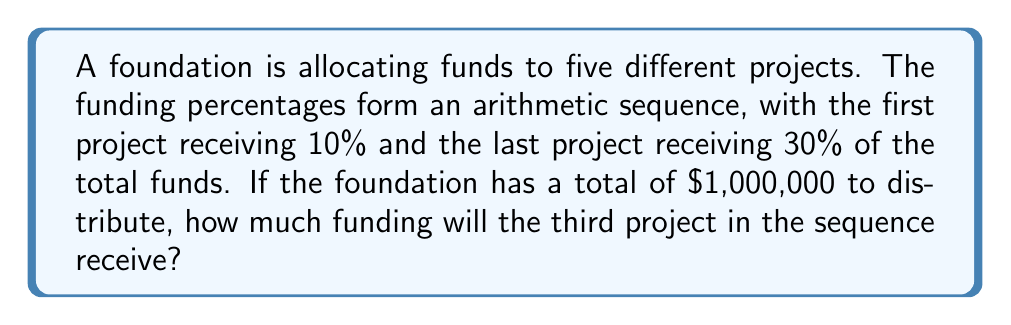Can you answer this question? Let's approach this step-by-step:

1) First, we need to identify the arithmetic sequence. We know:
   - The first term, $a_1 = 10\%$
   - The last term (5th term), $a_5 = 30\%$

2) In an arithmetic sequence, the difference between each term is constant. Let's call this common difference $d$. We can find it using the formula:

   $$ a_n = a_1 + (n-1)d $$

   Where $n$ is the number of terms (5 in this case).

3) Substituting our known values:

   $$ 30\% = 10\% + (5-1)d $$
   $$ 20\% = 4d $$
   $$ d = 5\% $$

4) Now we can find the third term in the sequence:

   $$ a_3 = a_1 + (3-1)d $$
   $$ a_3 = 10\% + (2)(5\%) $$
   $$ a_3 = 20\% $$

5) The third project will receive 20% of the total funds.

6) To calculate the actual amount:

   $$ 20\% \text{ of } \$1,000,000 = 0.20 \times \$1,000,000 = \$200,000 $$

Therefore, the third project will receive $200,000 in funding.
Answer: $200,000 